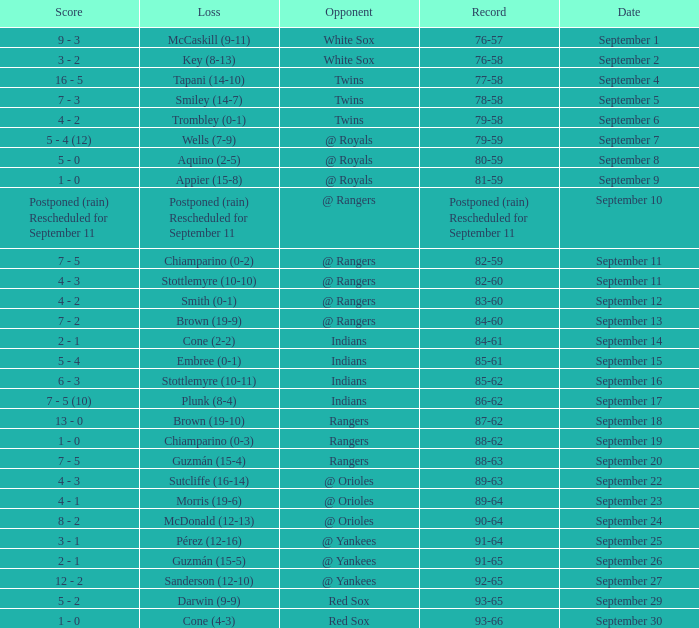Who is the rival with an 86-62 track record? Indians. 